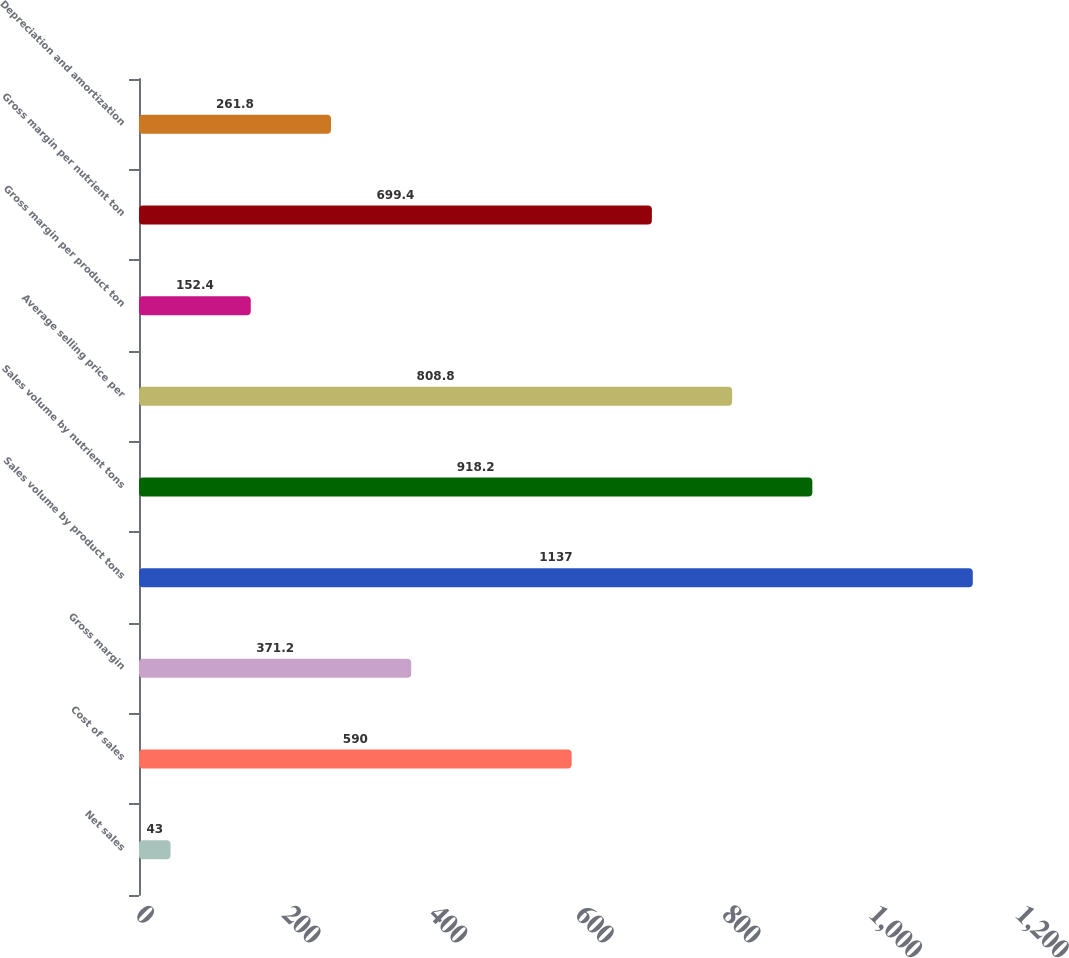Convert chart. <chart><loc_0><loc_0><loc_500><loc_500><bar_chart><fcel>Net sales<fcel>Cost of sales<fcel>Gross margin<fcel>Sales volume by product tons<fcel>Sales volume by nutrient tons<fcel>Average selling price per<fcel>Gross margin per product ton<fcel>Gross margin per nutrient ton<fcel>Depreciation and amortization<nl><fcel>43<fcel>590<fcel>371.2<fcel>1137<fcel>918.2<fcel>808.8<fcel>152.4<fcel>699.4<fcel>261.8<nl></chart> 